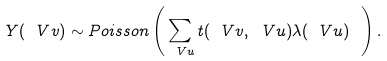<formula> <loc_0><loc_0><loc_500><loc_500>Y ( \ V { v } ) \sim P o i s s o n \left ( \sum _ { \ V { u } } t ( { \ V { v } } , \ V { u } ) \lambda ( \ V { u } ) \ \right ) .</formula> 